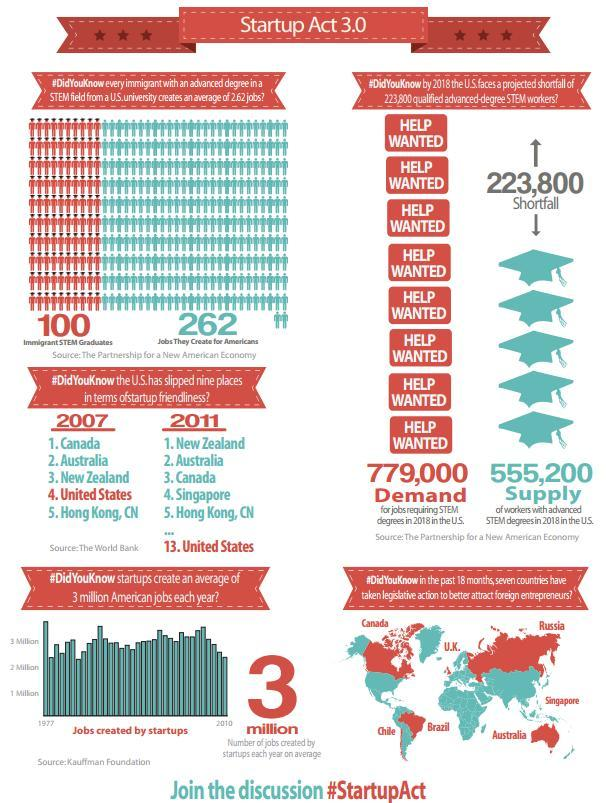In 1977 -2010 period, in which year did startup create the most number of jobs?
Answer the question with a short phrase. 1977 In startup friendliness, which country was ranked third in  2007 and first in 2011? New Zealand In last 18 months, which north  american country   made laws to attract foriegn entrepreneurs? Canada In startup friendliness, which country was ranked second in both 2007 and 2011? Australia In last 18 months , how many countries from latin america have made laws to attract foriegn entrepreneurs? 2 In last 18 months, which north asian country made laws to attract foriegn entrepreneurs? Singapore Which is the most startup friendly state in 2011? New Zealand 